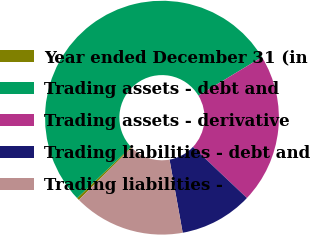<chart> <loc_0><loc_0><loc_500><loc_500><pie_chart><fcel>Year ended December 31 (in<fcel>Trading assets - debt and<fcel>Trading assets - derivative<fcel>Trading liabilities - debt and<fcel>Trading liabilities -<nl><fcel>0.34%<fcel>53.41%<fcel>20.73%<fcel>10.11%<fcel>15.42%<nl></chart> 